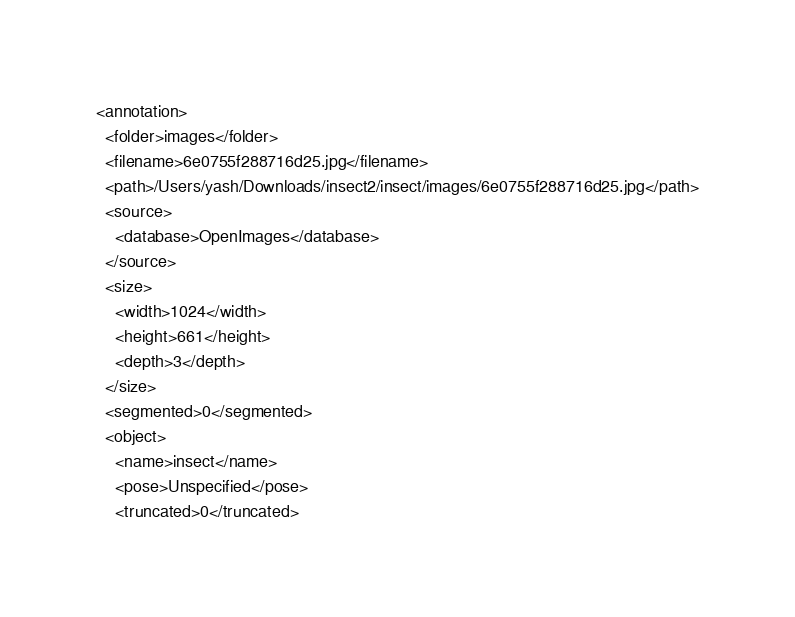Convert code to text. <code><loc_0><loc_0><loc_500><loc_500><_XML_><annotation>
  <folder>images</folder>
  <filename>6e0755f288716d25.jpg</filename>
  <path>/Users/yash/Downloads/insect2/insect/images/6e0755f288716d25.jpg</path>
  <source>
    <database>OpenImages</database>
  </source>
  <size>
    <width>1024</width>
    <height>661</height>
    <depth>3</depth>
  </size>
  <segmented>0</segmented>
  <object>
    <name>insect</name>
    <pose>Unspecified</pose>
    <truncated>0</truncated></code> 